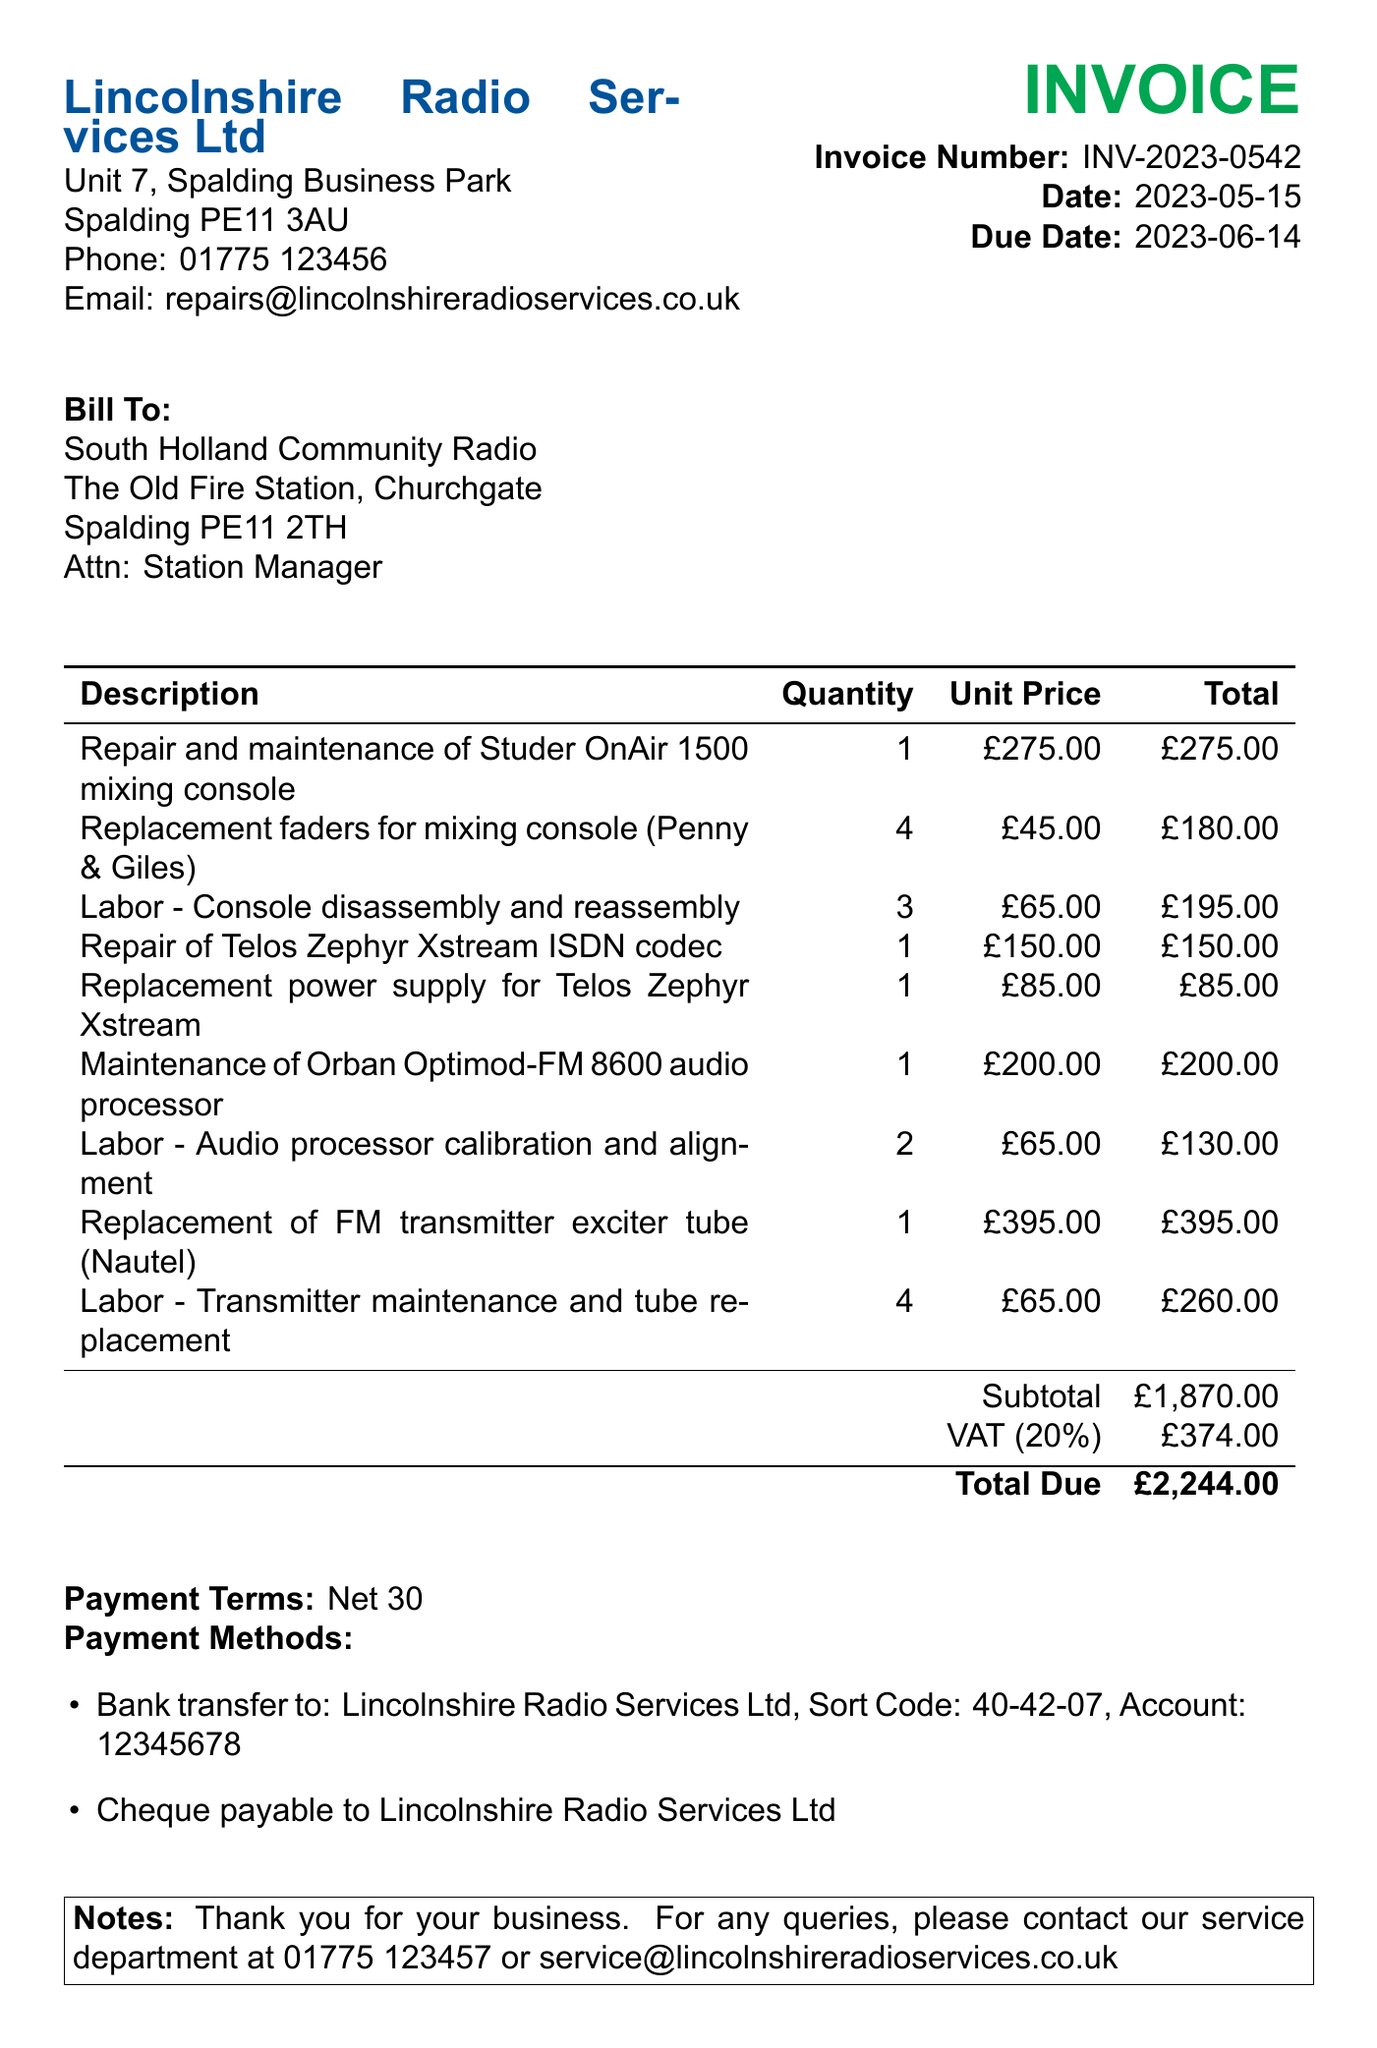What is the invoice number? The invoice number is found in the heading of the document, labeled as "Invoice Number:".
Answer: INV-2023-0542 What is the date of the invoice? The date of the invoice is specified next to "Date:" in the document.
Answer: 2023-05-15 Who is the invoice billed to? The recipient is found under the "Bill To:" section which provides the name and address of the client.
Answer: South Holland Community Radio How much is the VAT amount? The VAT amount is listed in the table under "VAT (20%)".
Answer: £374.00 What is the total due? The total amount due is found in the last row of the table and is highlighted as "Total Due".
Answer: £2,244.00 How many replacement faders were included in the invoice? The quantity of replacement faders is provided in the itemized list of the invoice under the "Quantity" column.
Answer: 4 What is the payment term? The payment term is stated under the "Payment Terms:" section of the document.
Answer: Net 30 What type of labor is listed for console maintenance? The labor description is provided in the itemized list where specific services are described.
Answer: Console disassembly and reassembly What is the unit price for the replacement power supply? The unit price is found in the itemized list specifically next to the "Replacement power supply for Telos Zephyr Xstream".
Answer: £85.00 